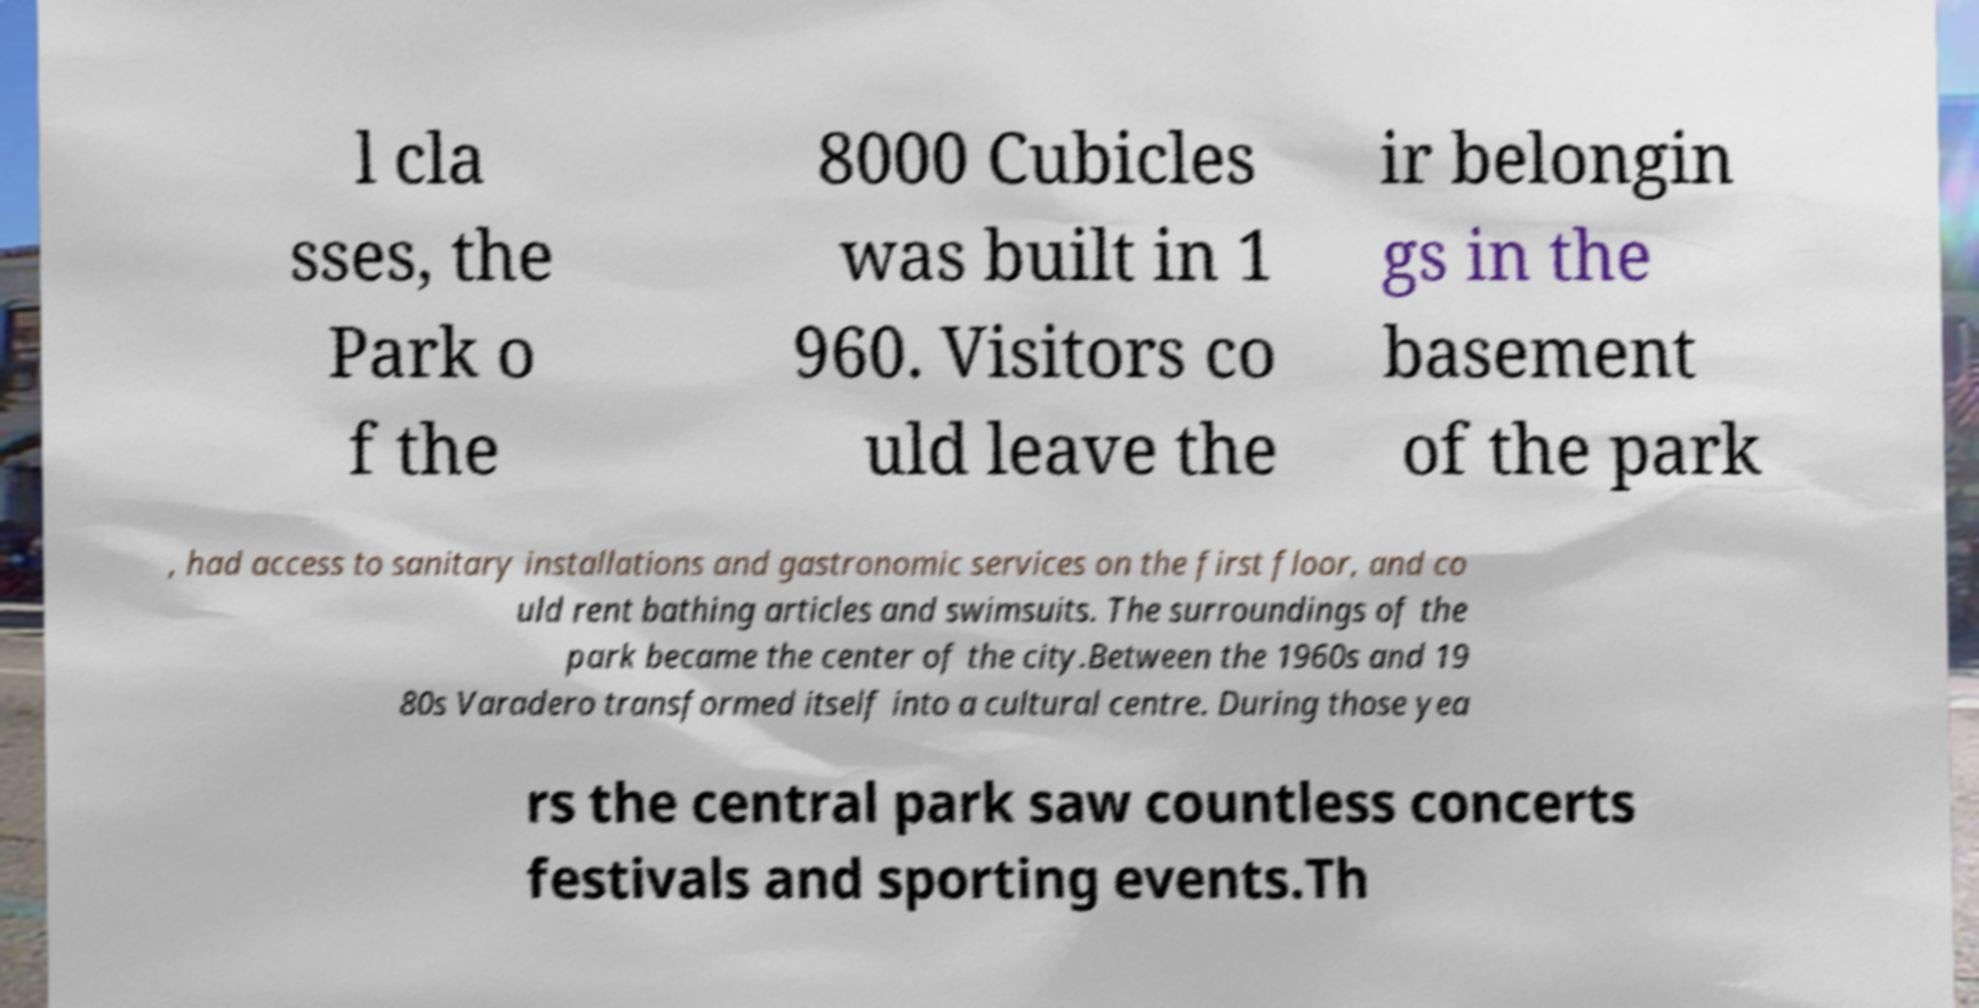Please read and relay the text visible in this image. What does it say? l cla sses, the Park o f the 8000 Cubicles was built in 1 960. Visitors co uld leave the ir belongin gs in the basement of the park , had access to sanitary installations and gastronomic services on the first floor, and co uld rent bathing articles and swimsuits. The surroundings of the park became the center of the city.Between the 1960s and 19 80s Varadero transformed itself into a cultural centre. During those yea rs the central park saw countless concerts festivals and sporting events.Th 